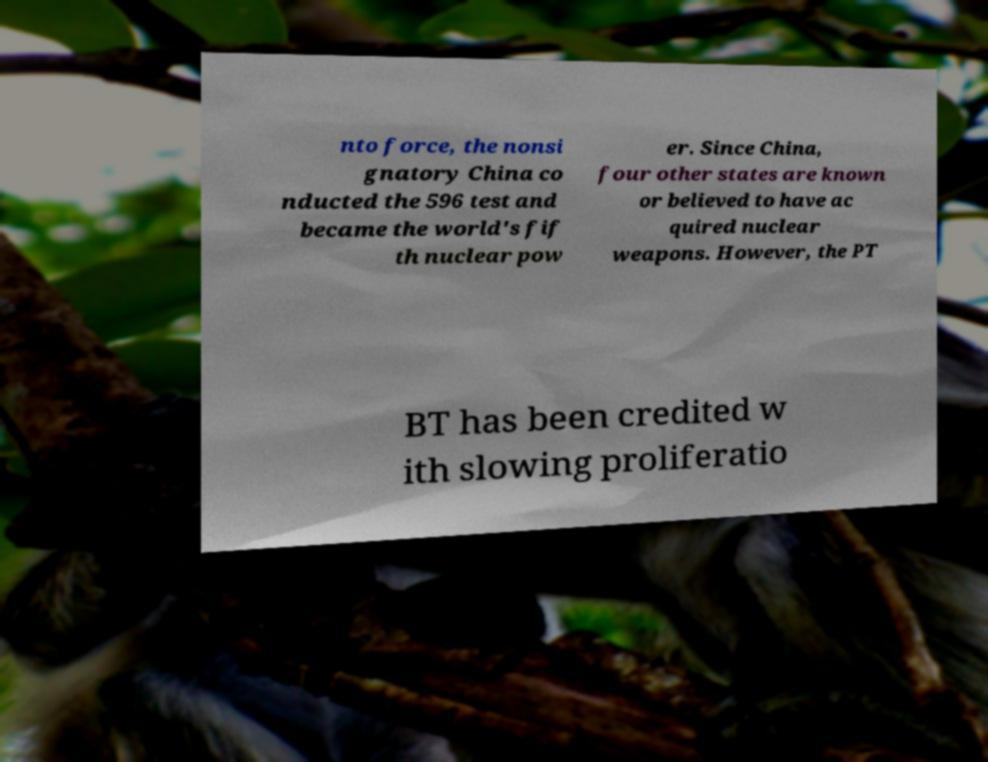There's text embedded in this image that I need extracted. Can you transcribe it verbatim? nto force, the nonsi gnatory China co nducted the 596 test and became the world's fif th nuclear pow er. Since China, four other states are known or believed to have ac quired nuclear weapons. However, the PT BT has been credited w ith slowing proliferatio 